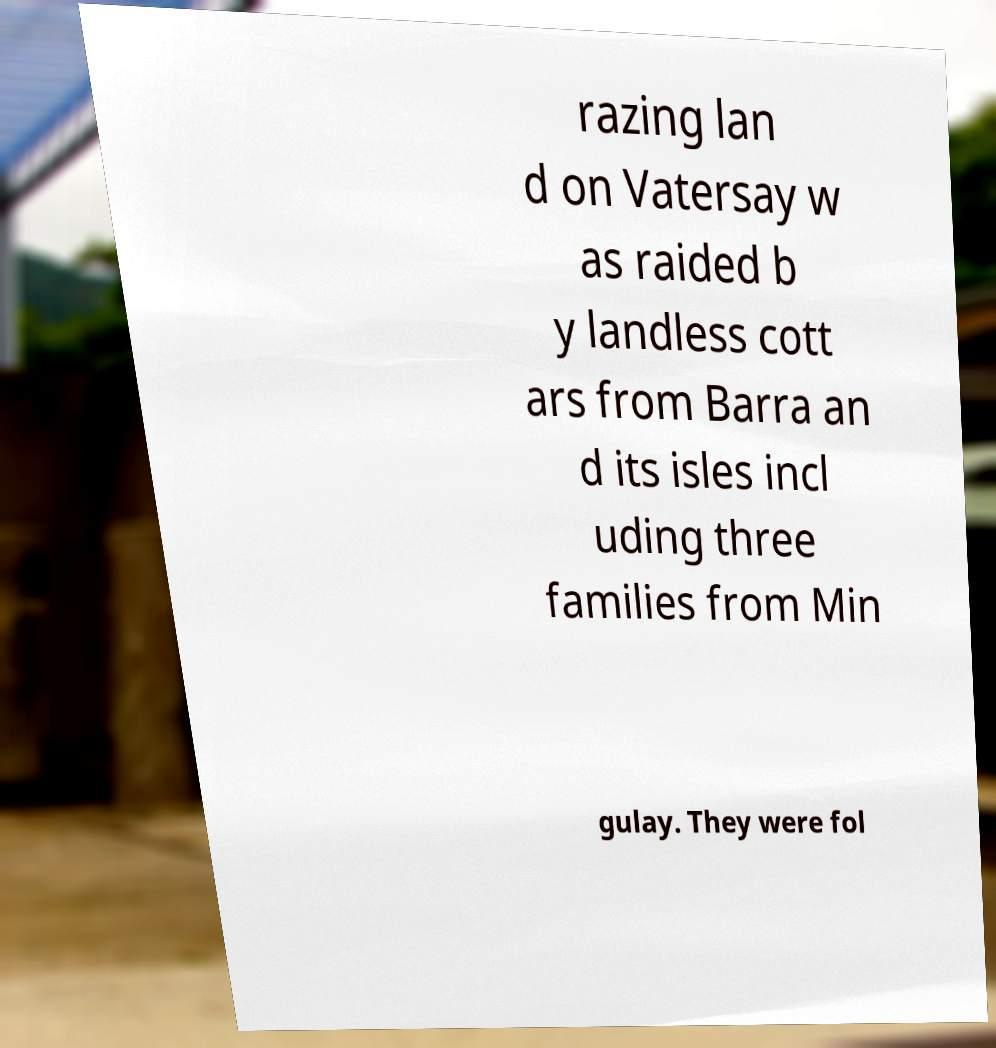Can you read and provide the text displayed in the image?This photo seems to have some interesting text. Can you extract and type it out for me? razing lan d on Vatersay w as raided b y landless cott ars from Barra an d its isles incl uding three families from Min gulay. They were fol 